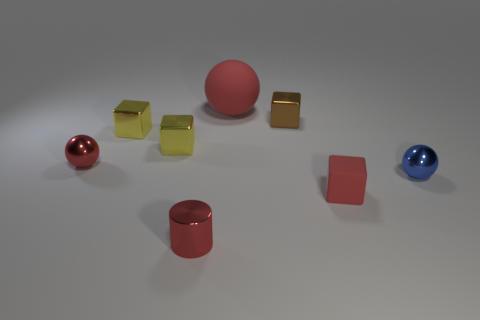There is a tiny metal ball to the left of the big rubber object; does it have the same color as the tiny metallic cylinder? Yes, the small metal ball on the left shares the same hue of red as the tiny metallic cylinder. 